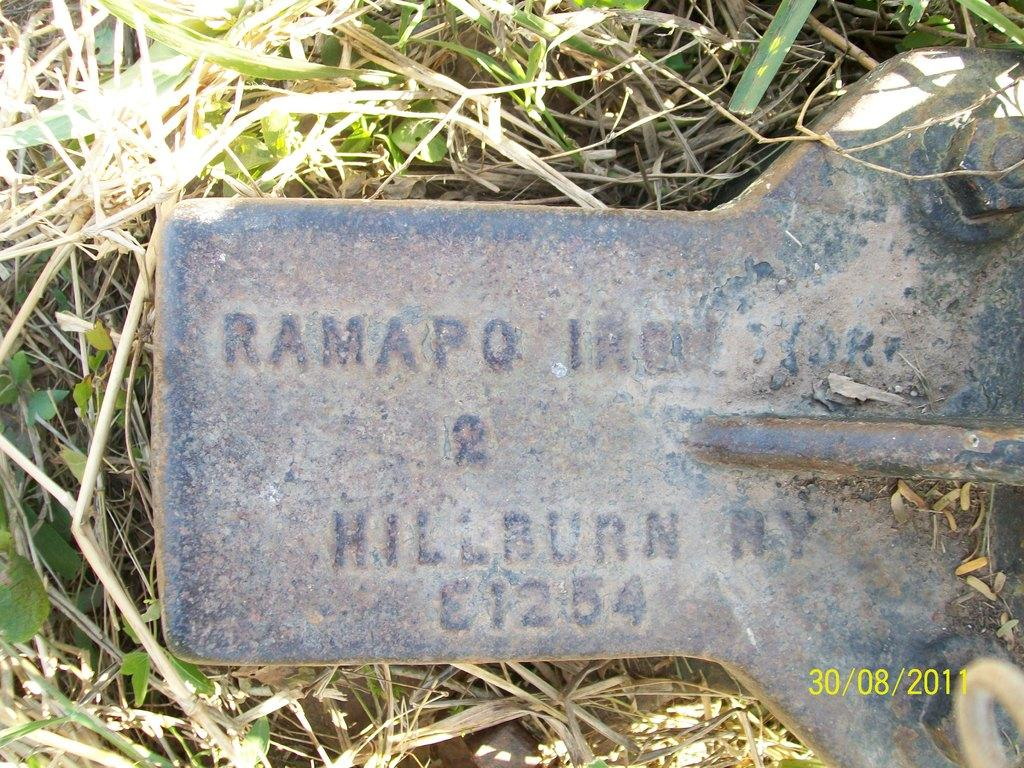What type of object is made of metal and has text in the image? There is a metal piece with text in the image. What other objects can be seen in the image that are related to the metal piece? There is a set of bolts in the image. What type of living organisms are present in the image? There are plants in the image. What type of substance is being cut with the scissors in the image? There are no scissors present in the image. What type of comfort can be found in the image? The image does not depict any objects or elements related to comfort. 